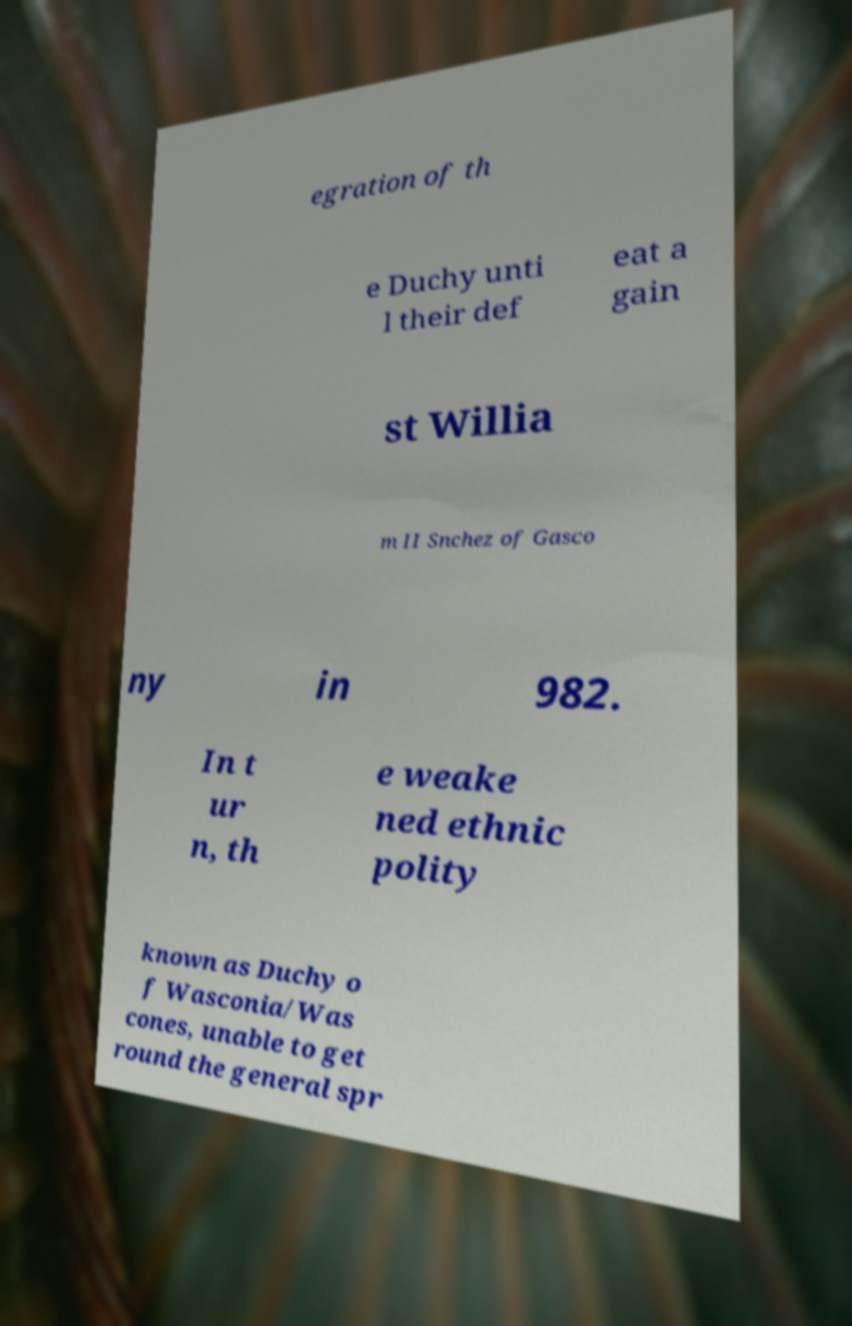There's text embedded in this image that I need extracted. Can you transcribe it verbatim? egration of th e Duchy unti l their def eat a gain st Willia m II Snchez of Gasco ny in 982. In t ur n, th e weake ned ethnic polity known as Duchy o f Wasconia/Was cones, unable to get round the general spr 